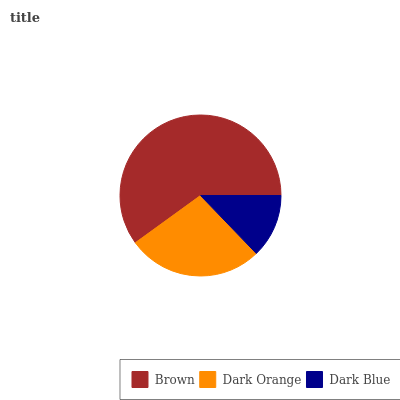Is Dark Blue the minimum?
Answer yes or no. Yes. Is Brown the maximum?
Answer yes or no. Yes. Is Dark Orange the minimum?
Answer yes or no. No. Is Dark Orange the maximum?
Answer yes or no. No. Is Brown greater than Dark Orange?
Answer yes or no. Yes. Is Dark Orange less than Brown?
Answer yes or no. Yes. Is Dark Orange greater than Brown?
Answer yes or no. No. Is Brown less than Dark Orange?
Answer yes or no. No. Is Dark Orange the high median?
Answer yes or no. Yes. Is Dark Orange the low median?
Answer yes or no. Yes. Is Brown the high median?
Answer yes or no. No. Is Brown the low median?
Answer yes or no. No. 